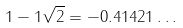Convert formula to latex. <formula><loc_0><loc_0><loc_500><loc_500>1 - 1 \sqrt { 2 } = - 0 . 4 1 4 2 1 \dots</formula> 